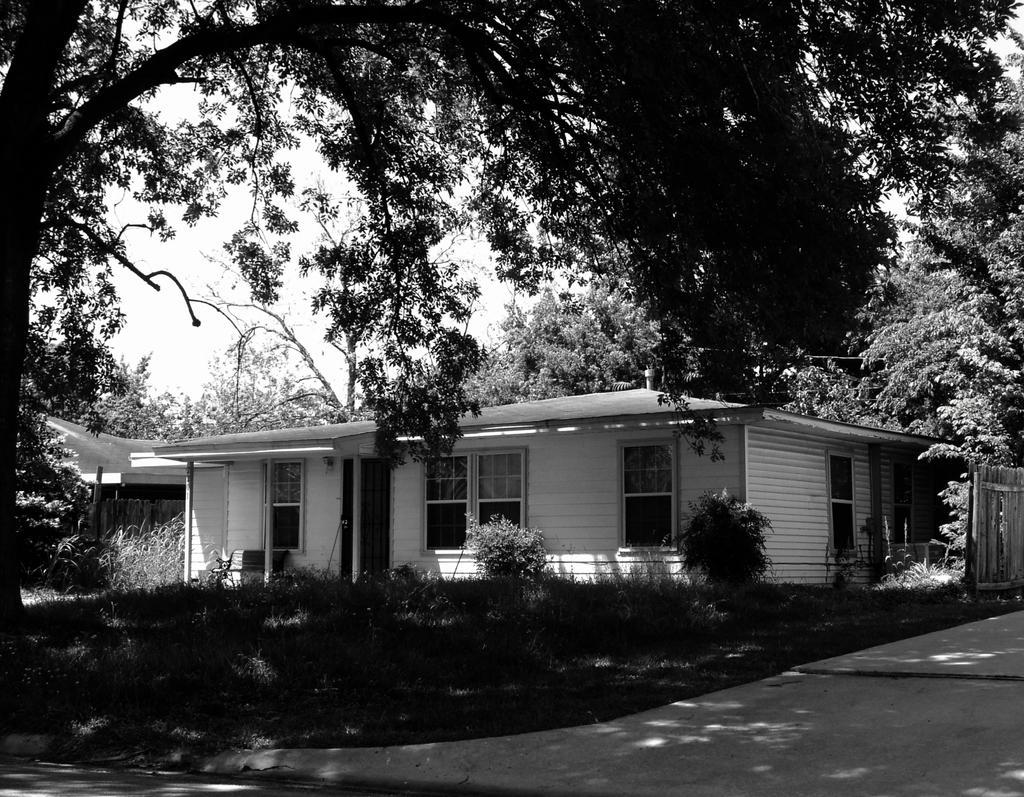Describe this image in one or two sentences. In this image I can see a building. I can see few plants on the ground. I can see few trees. At the top I can see the sky. 